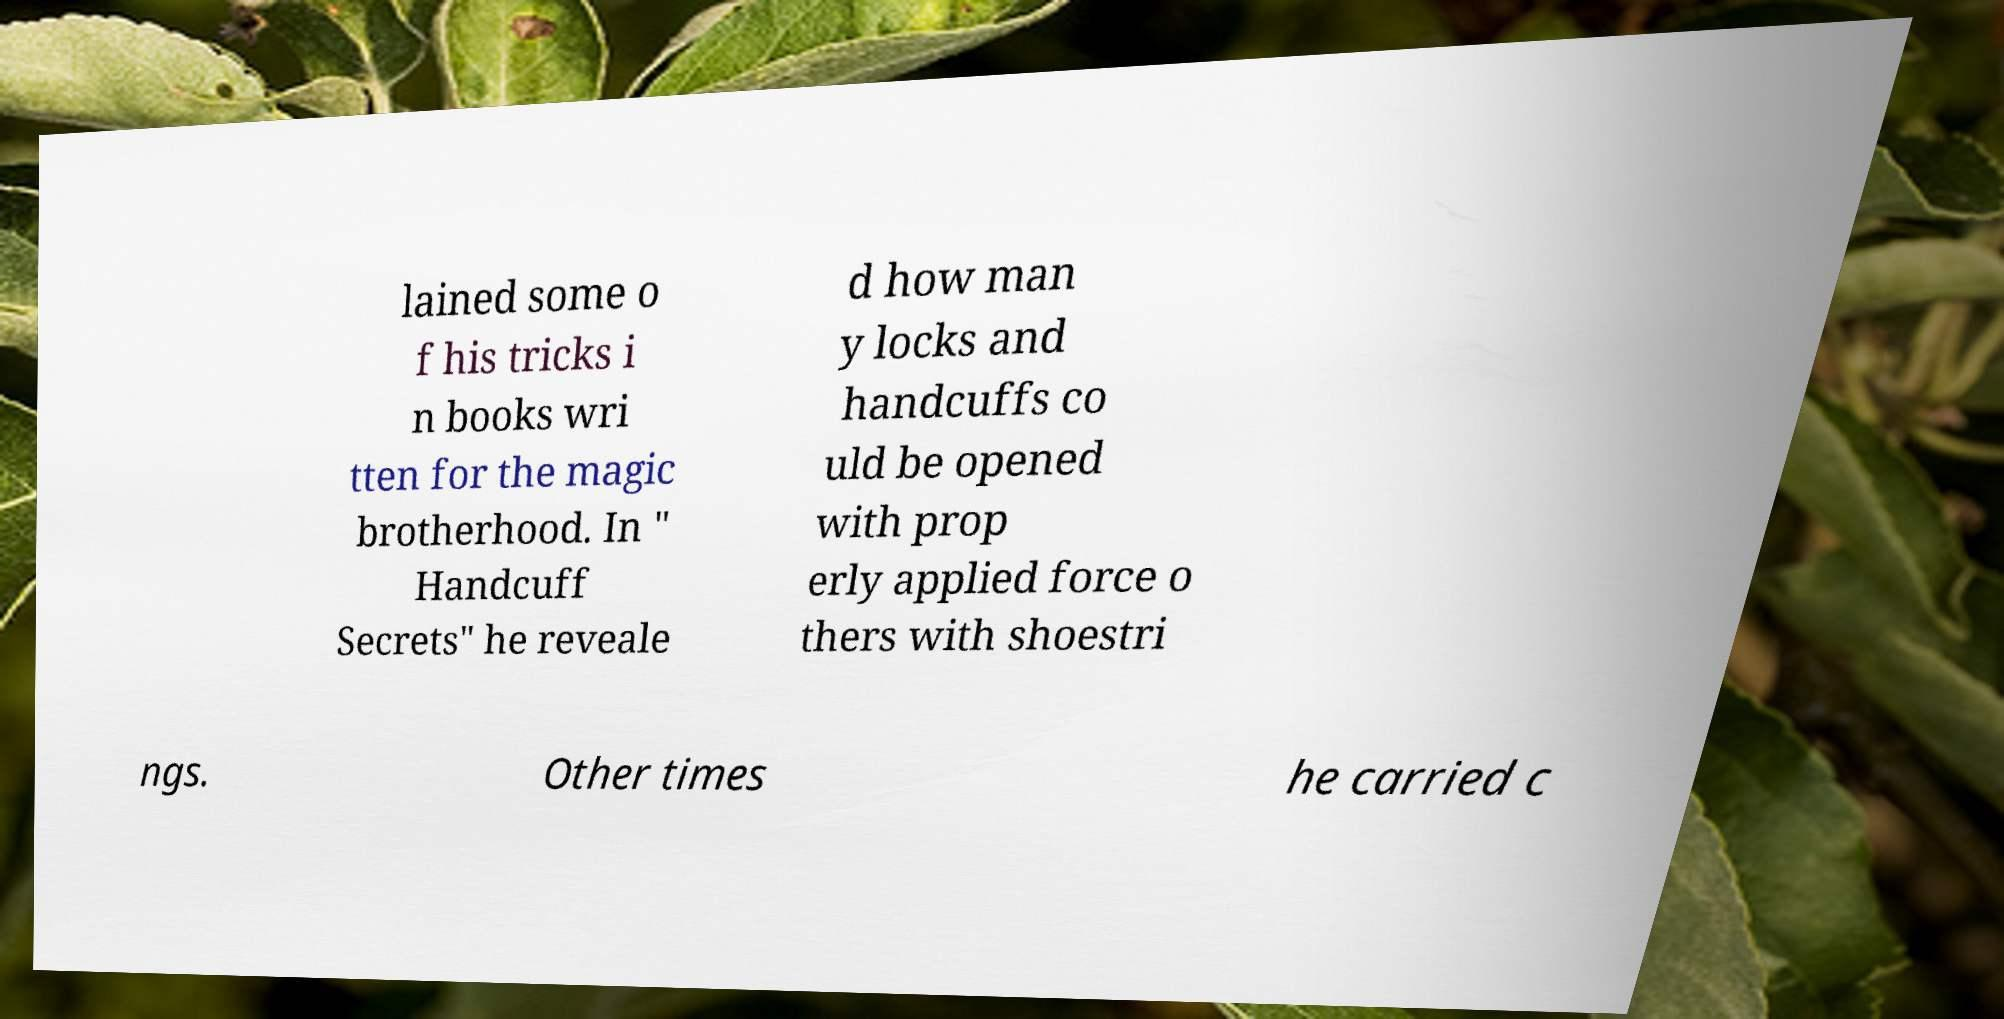Please identify and transcribe the text found in this image. lained some o f his tricks i n books wri tten for the magic brotherhood. In " Handcuff Secrets" he reveale d how man y locks and handcuffs co uld be opened with prop erly applied force o thers with shoestri ngs. Other times he carried c 